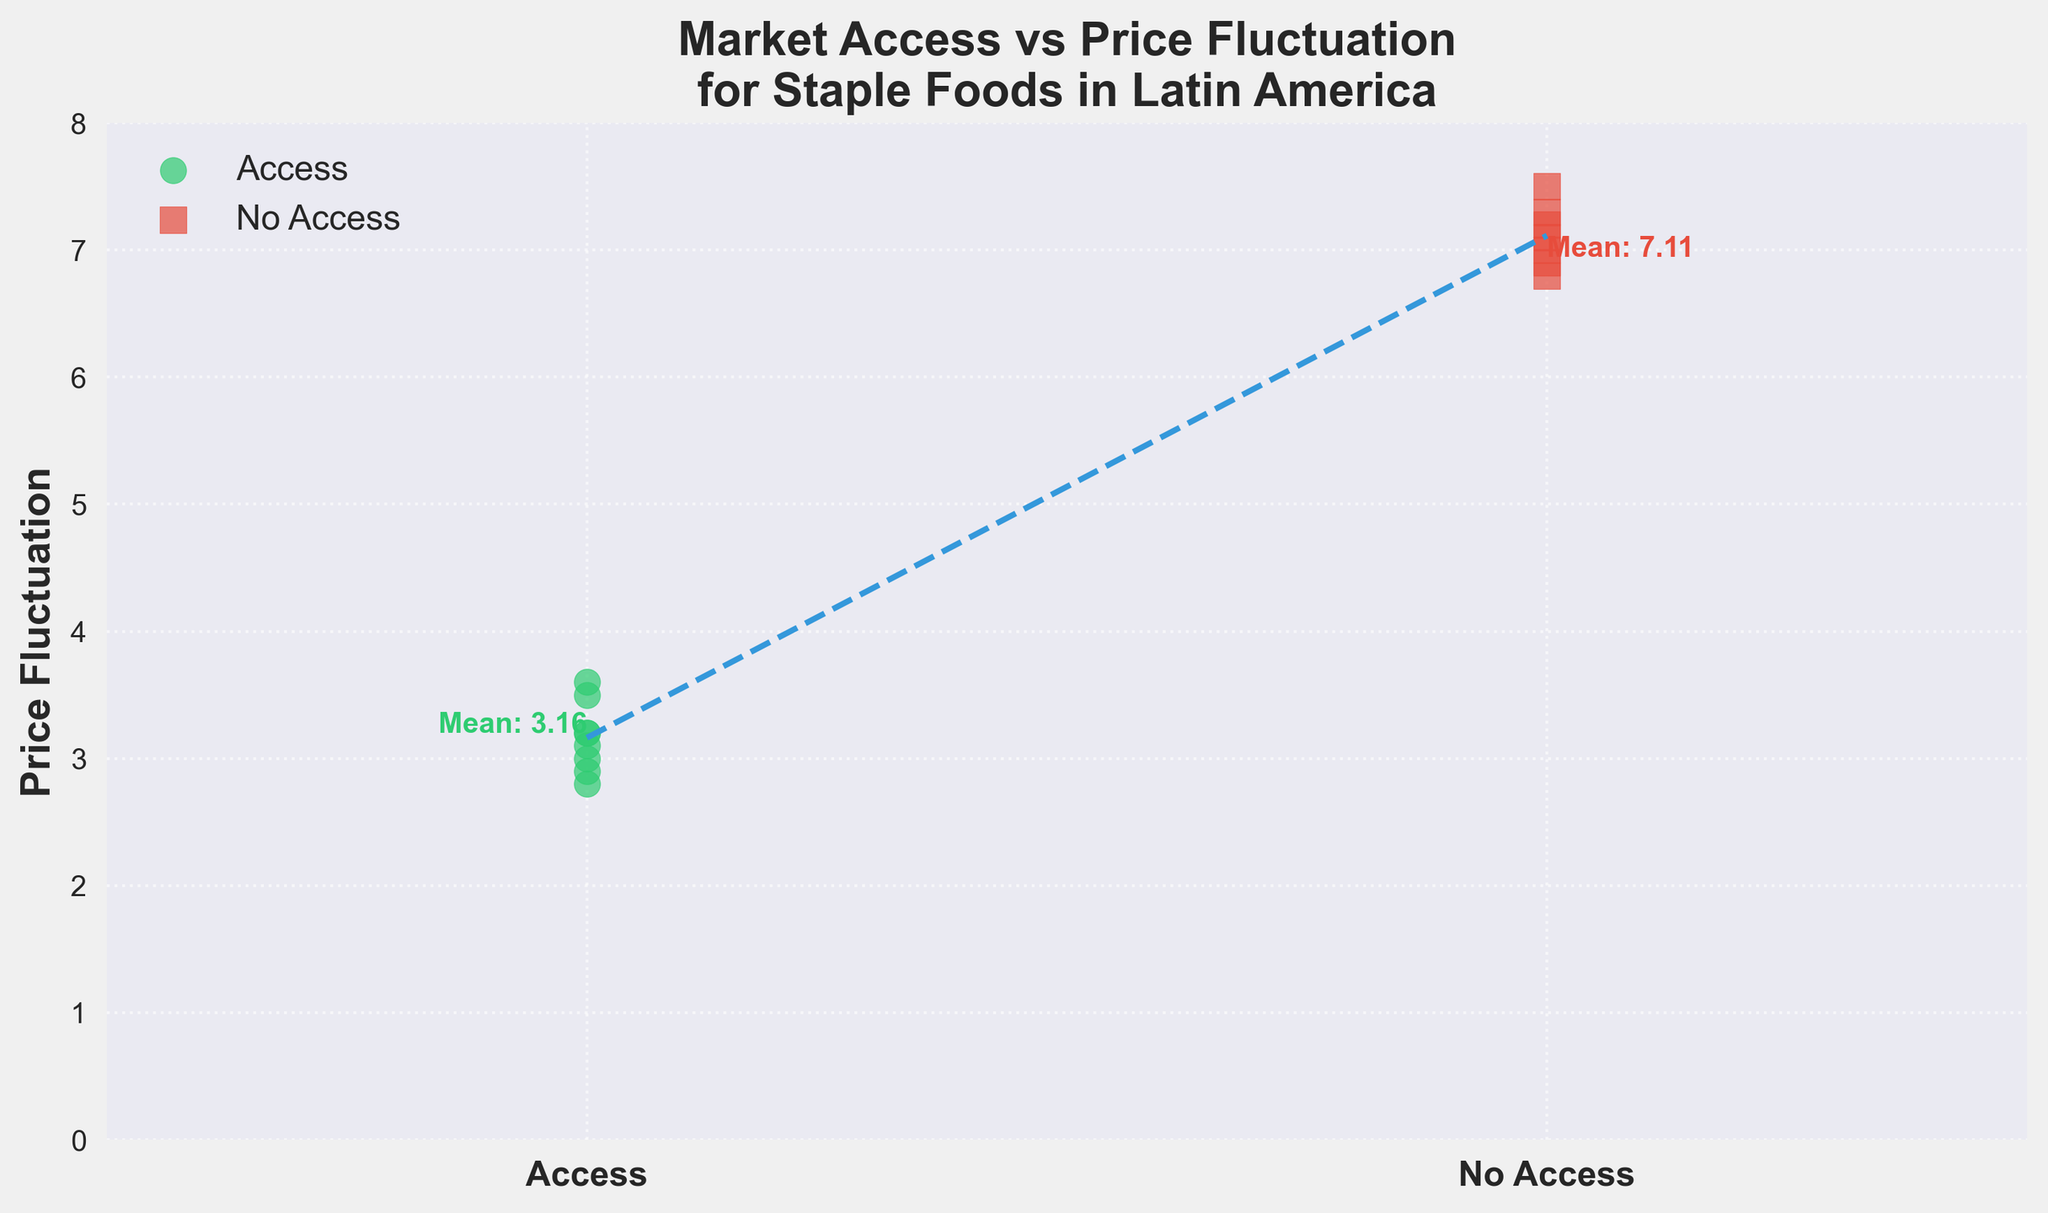what is the title of the figure? The title of the figure can be read directly from the top of the plot.
Answer: Market Access vs Price Fluctuation for Staple Foods in Latin America What do the colors green and red represent in the plot? The legend in the plot specifies that green represents 'Access' and red represents 'No Access'.
Answer: Green represents 'Access' and red represents 'No Access' What is the average price fluctuation for areas with market access? The plot includes an annotation at the access cluster that states the average price fluctuation.
Answer: 3.17 What is the average price fluctuation without market access? Similarly, the average price fluctuation for the no access group is annotated next to the no access cluster.
Answer: 7.13 Which group has higher price fluctuation? By comparing the mean annotations or the trend line, it is clear that the no access group has a higher average price fluctuation.
Answer: No Access How many data points are there in the 'No Access' group? By visually counting the red squares in the plot, we can determine the number of data points in the 'No Access' group.
Answer: 7 What trend can be observed from the plot regarding market access and price fluctuation? The plot shows a trend line indicating that price fluctuations are generally lower in regions with market access compared to regions without market access.
Answer: Price fluctuations are lower in regions with market access How many more points are in the 'No Access' group compared to the 'Access' group? Count the green circles (8) and red squares (7), then determine the difference.
Answer: 1 fewer point in 'No Access' What is the visual difference in marker shape between the two groups? The plot legend indicates that 'Access' is represented by circles and 'No Access' by squares.
Answer: Circles for 'Access' and squares for 'No Access' What is the general pattern observed in the fluctuation of prices for staple foods in this plot? From the scatter plot and the trend line, it is observable that staple foods' price fluctuations are generally more stable (lower) in areas with market access.
Answer: More stable in areas with market access 